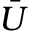<formula> <loc_0><loc_0><loc_500><loc_500>\bar { U }</formula> 